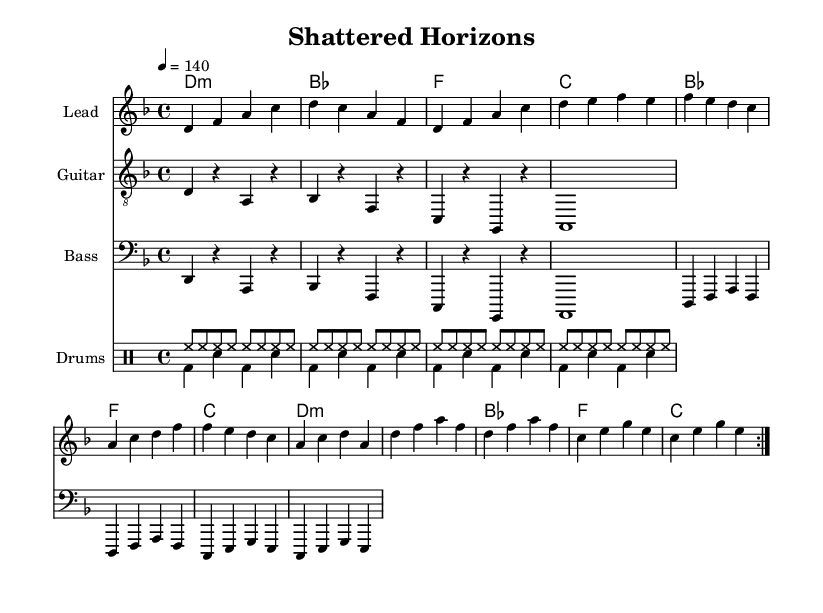What is the key signature of this music? The key signature is D minor, indicated by one flat (B♭) in the key signature. This can be seen at the beginning of the staff.
Answer: D minor What is the time signature of this music? The time signature is 4/4, which means there are four beats in each measure, and the quarter note receives one beat. This is shown at the beginning of the score.
Answer: 4/4 What is the tempo marking in the music? The tempo marking indicates a speed of 140 beats per minute, shown by the tempo setting at the beginning of the score.
Answer: 140 How many measures are repeated in the melody section? The melody section indicates that the first part is repeated twice, which is indicated by the "volta" markings in the repeat sections.
Answer: 2 What type of drum patterns are used in the drums section? The drums section contains two distinct patterns: the first is a consistent hi-hat pattern, and the second features bass and snare hits. This can be identified by the arrangement of note types in the drum staff.
Answer: Hi-hat and bass/snare What is the highest note in the guitar riff? The highest note in the guitar riff is A, which is evident in the guitar staff where the notes are arranged in ascending order within the measure.
Answer: A How many different sections are there in the harmonies? The harmonies section consists of two parts, with a repeated structure indicated by the volta markings, showing the same harmonic progression is played again.
Answer: 2 